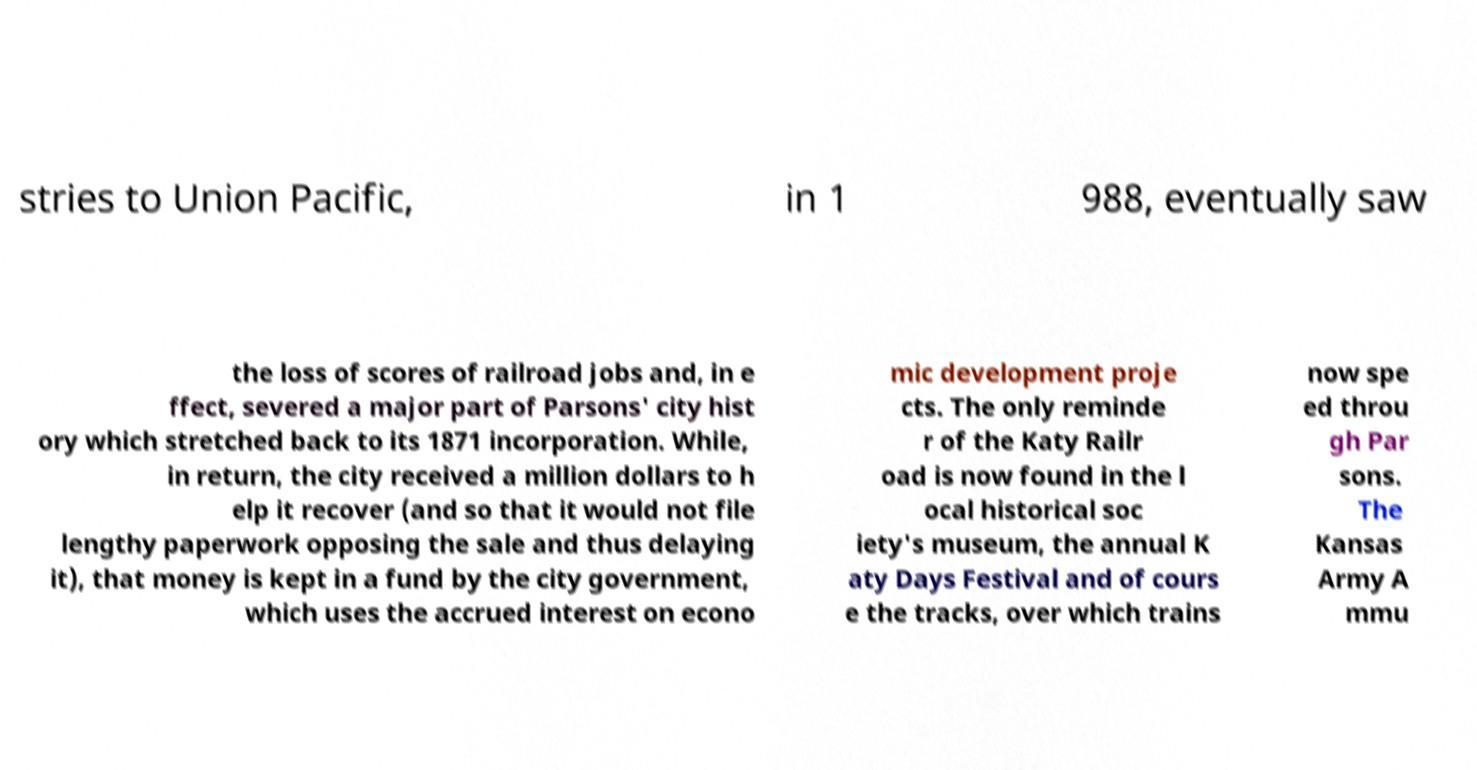Can you accurately transcribe the text from the provided image for me? stries to Union Pacific, in 1 988, eventually saw the loss of scores of railroad jobs and, in e ffect, severed a major part of Parsons' city hist ory which stretched back to its 1871 incorporation. While, in return, the city received a million dollars to h elp it recover (and so that it would not file lengthy paperwork opposing the sale and thus delaying it), that money is kept in a fund by the city government, which uses the accrued interest on econo mic development proje cts. The only reminde r of the Katy Railr oad is now found in the l ocal historical soc iety's museum, the annual K aty Days Festival and of cours e the tracks, over which trains now spe ed throu gh Par sons. The Kansas Army A mmu 